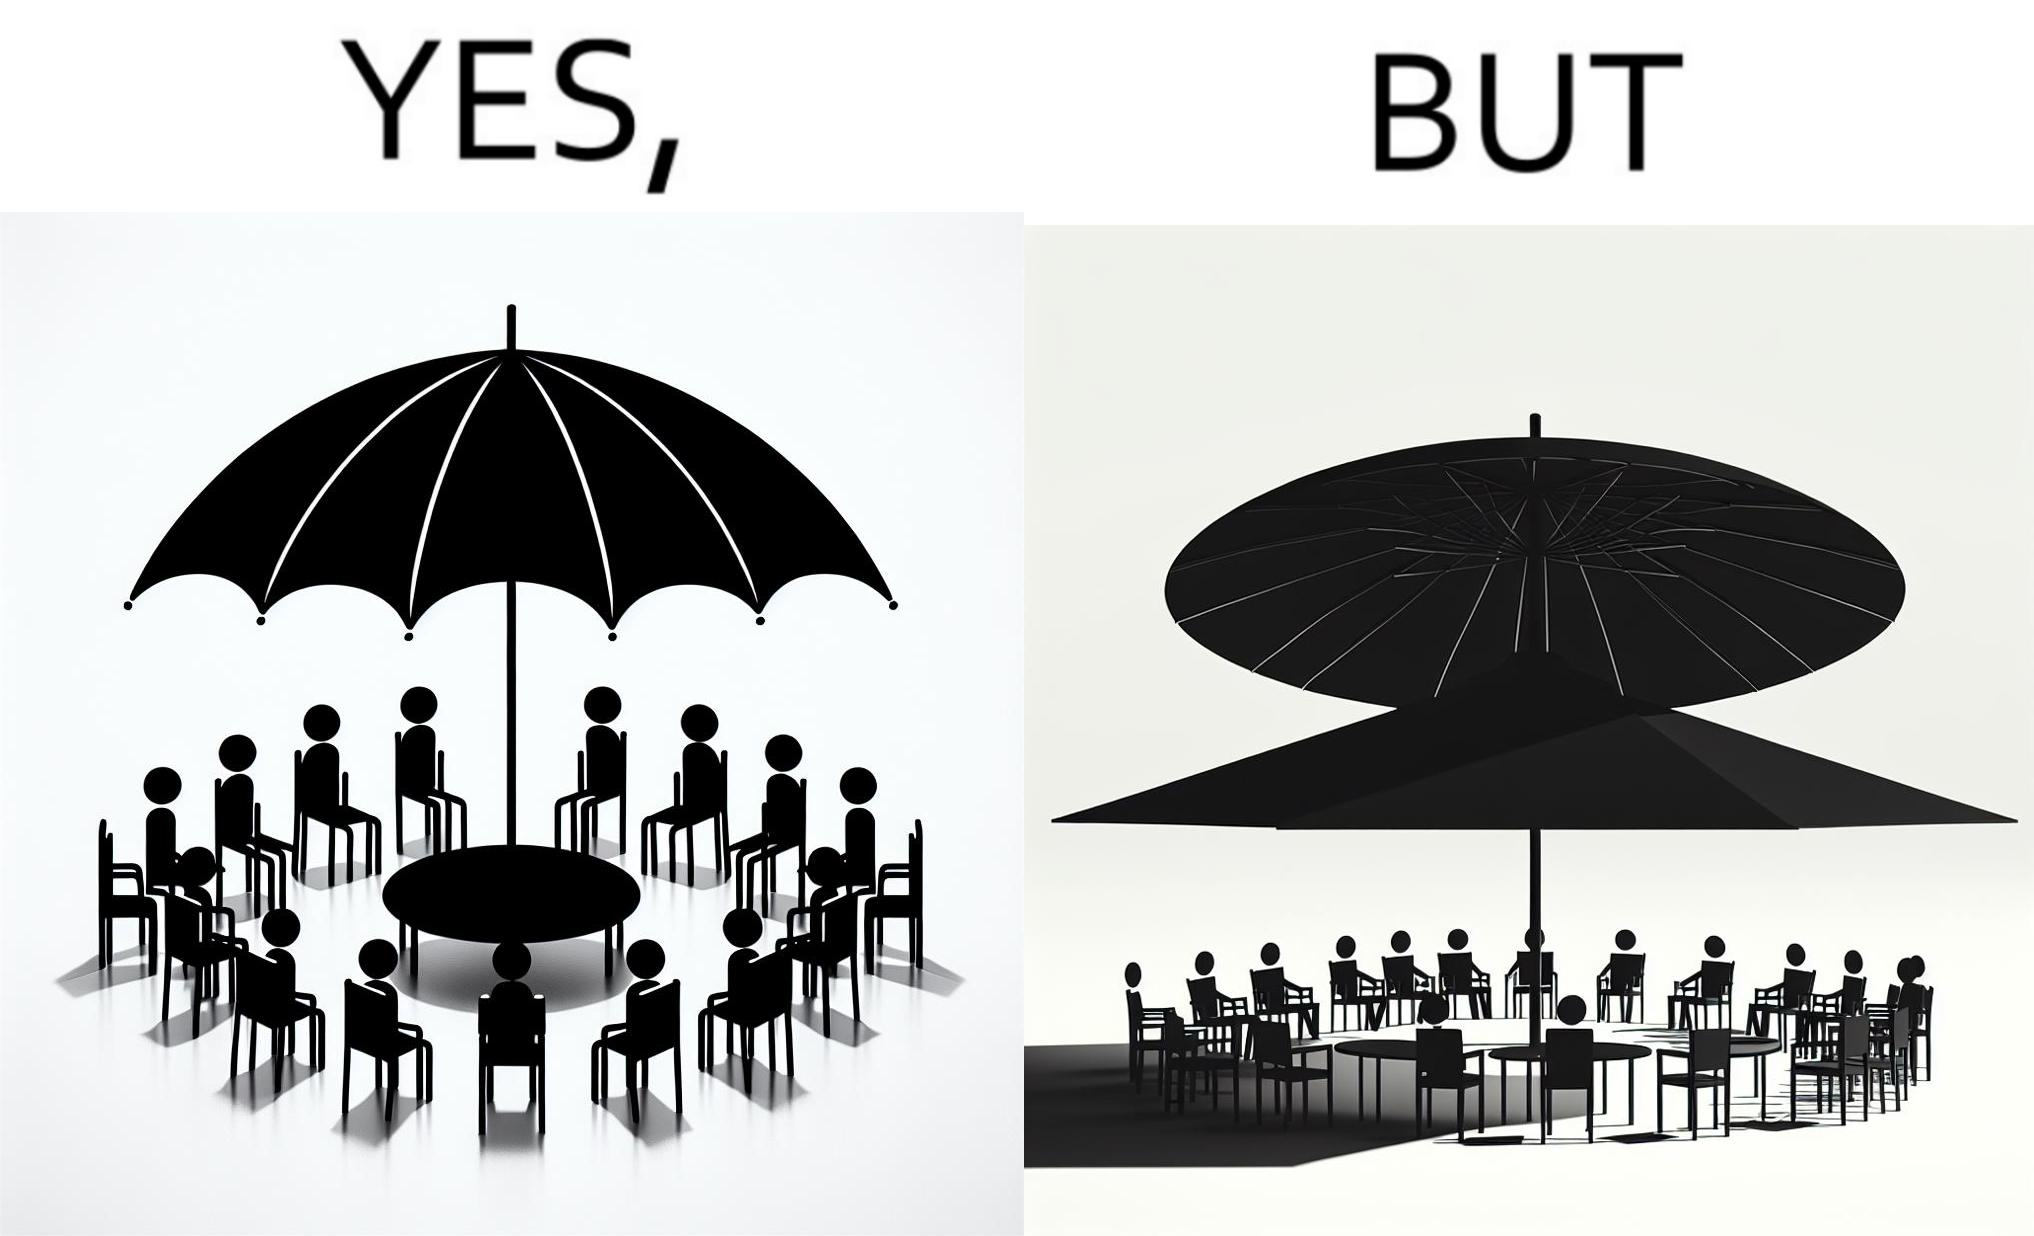Describe what you see in the left and right parts of this image. In the left part of the image: Chairs surrounding a table under a large umbrella. In the right part of the image: Chairs surrounding a table under a large umbrella, with the shadow of the umbrella appearing on the side. 